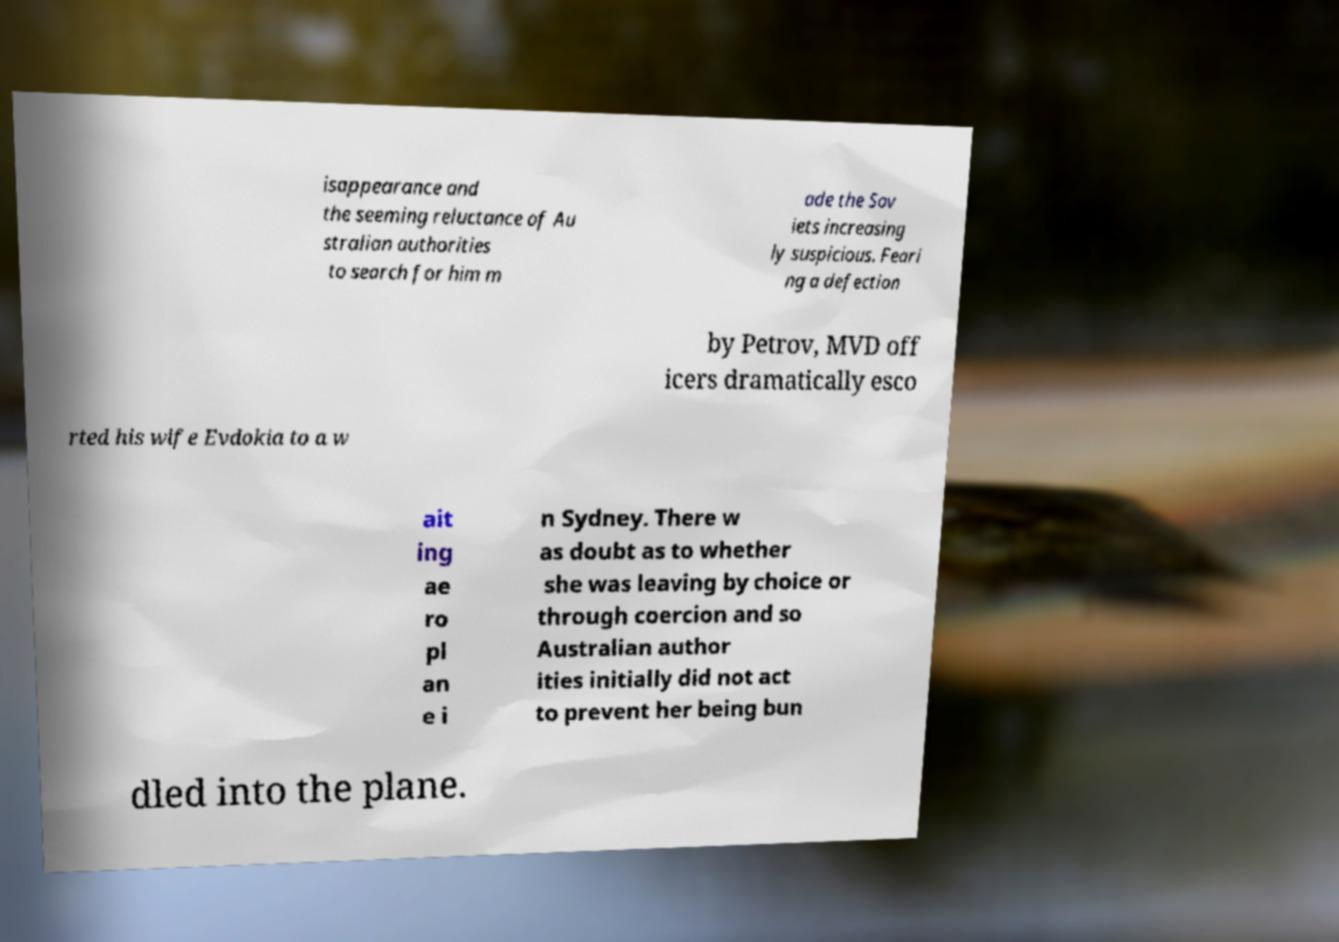Can you read and provide the text displayed in the image?This photo seems to have some interesting text. Can you extract and type it out for me? isappearance and the seeming reluctance of Au stralian authorities to search for him m ade the Sov iets increasing ly suspicious. Feari ng a defection by Petrov, MVD off icers dramatically esco rted his wife Evdokia to a w ait ing ae ro pl an e i n Sydney. There w as doubt as to whether she was leaving by choice or through coercion and so Australian author ities initially did not act to prevent her being bun dled into the plane. 